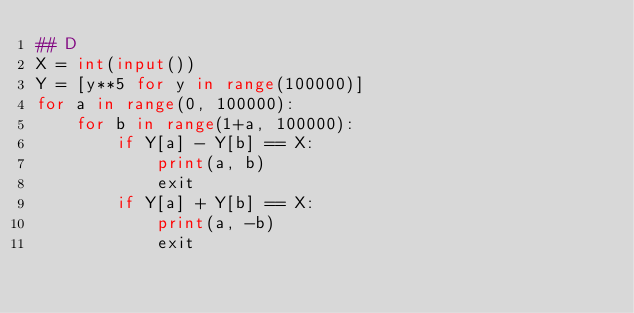Convert code to text. <code><loc_0><loc_0><loc_500><loc_500><_Python_>## D
X = int(input())
Y = [y**5 for y in range(100000)]
for a in range(0, 100000):
    for b in range(1+a, 100000):
        if Y[a] - Y[b] == X:
            print(a, b)
            exit
        if Y[a] + Y[b] == X:
            print(a, -b)
            exit</code> 